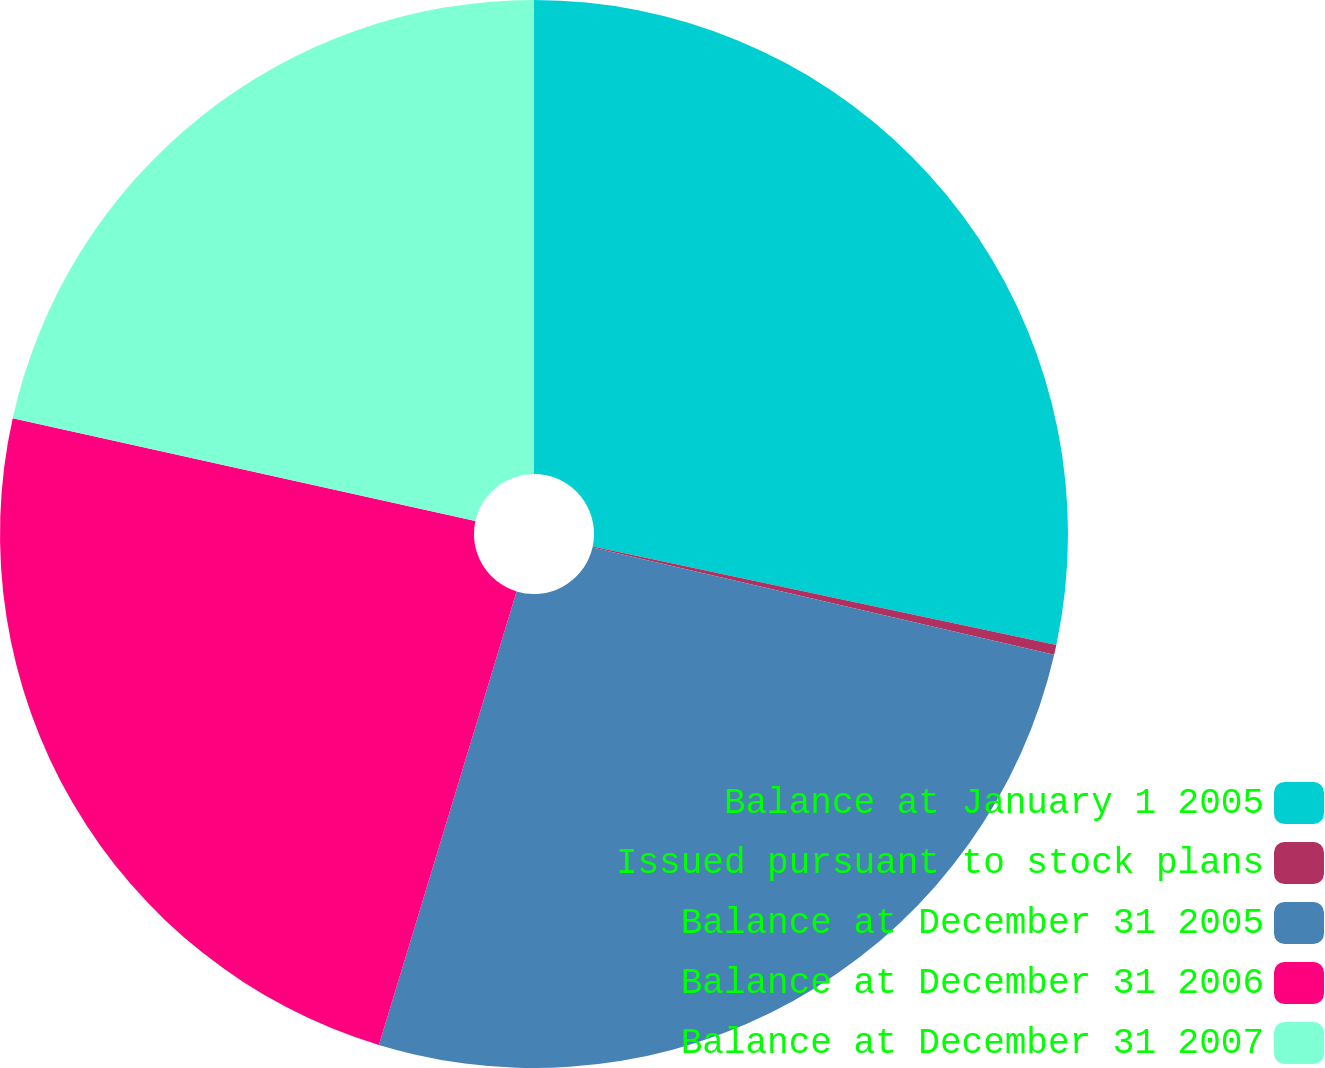Convert chart to OTSL. <chart><loc_0><loc_0><loc_500><loc_500><pie_chart><fcel>Balance at January 1 2005<fcel>Issued pursuant to stock plans<fcel>Balance at December 31 2005<fcel>Balance at December 31 2006<fcel>Balance at December 31 2007<nl><fcel>28.33%<fcel>0.3%<fcel>26.06%<fcel>23.79%<fcel>21.52%<nl></chart> 